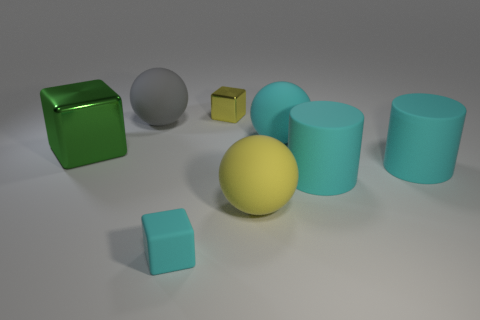Add 1 balls. How many objects exist? 9 Subtract all balls. How many objects are left? 5 Add 7 big yellow rubber objects. How many big yellow rubber objects are left? 8 Add 3 tiny matte things. How many tiny matte things exist? 4 Subtract 0 blue blocks. How many objects are left? 8 Subtract all cyan cylinders. Subtract all small yellow metal objects. How many objects are left? 5 